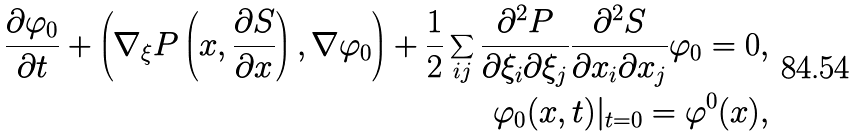<formula> <loc_0><loc_0><loc_500><loc_500>\frac { \partial \varphi _ { 0 } } { \partial t } + \left ( \nabla _ { \xi } P \left ( x , \frac { \partial S } { \partial x } \right ) , \nabla \varphi _ { 0 } \right ) + \frac { 1 } { 2 } \sum _ { i j } \frac { \partial ^ { 2 } P } { \partial \xi _ { i } \partial \xi _ { j } } \frac { \partial ^ { 2 } S } { \partial x _ { i } \partial x _ { j } } \varphi _ { 0 } = 0 , \\ \varphi _ { 0 } ( x , t ) | _ { t = 0 } = \varphi ^ { 0 } ( x ) ,</formula> 